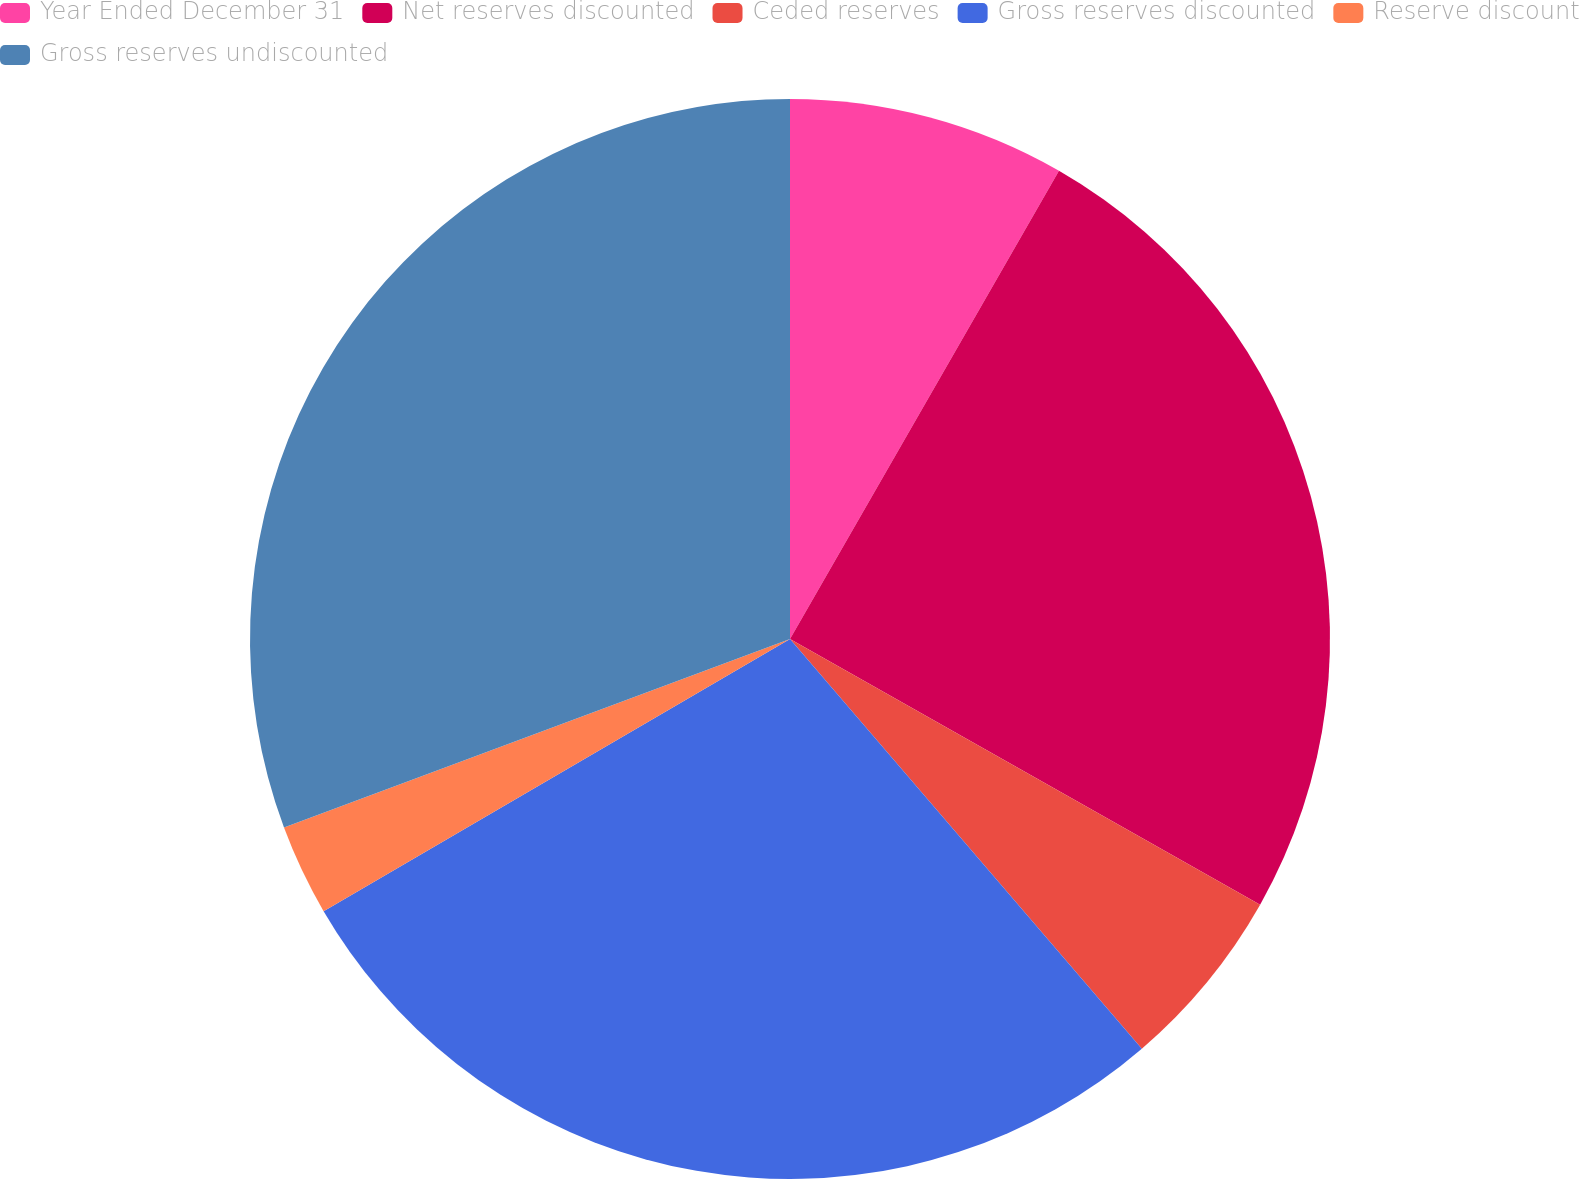Convert chart to OTSL. <chart><loc_0><loc_0><loc_500><loc_500><pie_chart><fcel>Year Ended December 31<fcel>Net reserves discounted<fcel>Ceded reserves<fcel>Gross reserves discounted<fcel>Reserve discount<fcel>Gross reserves undiscounted<nl><fcel>8.3%<fcel>24.89%<fcel>5.52%<fcel>27.89%<fcel>2.73%<fcel>30.68%<nl></chart> 